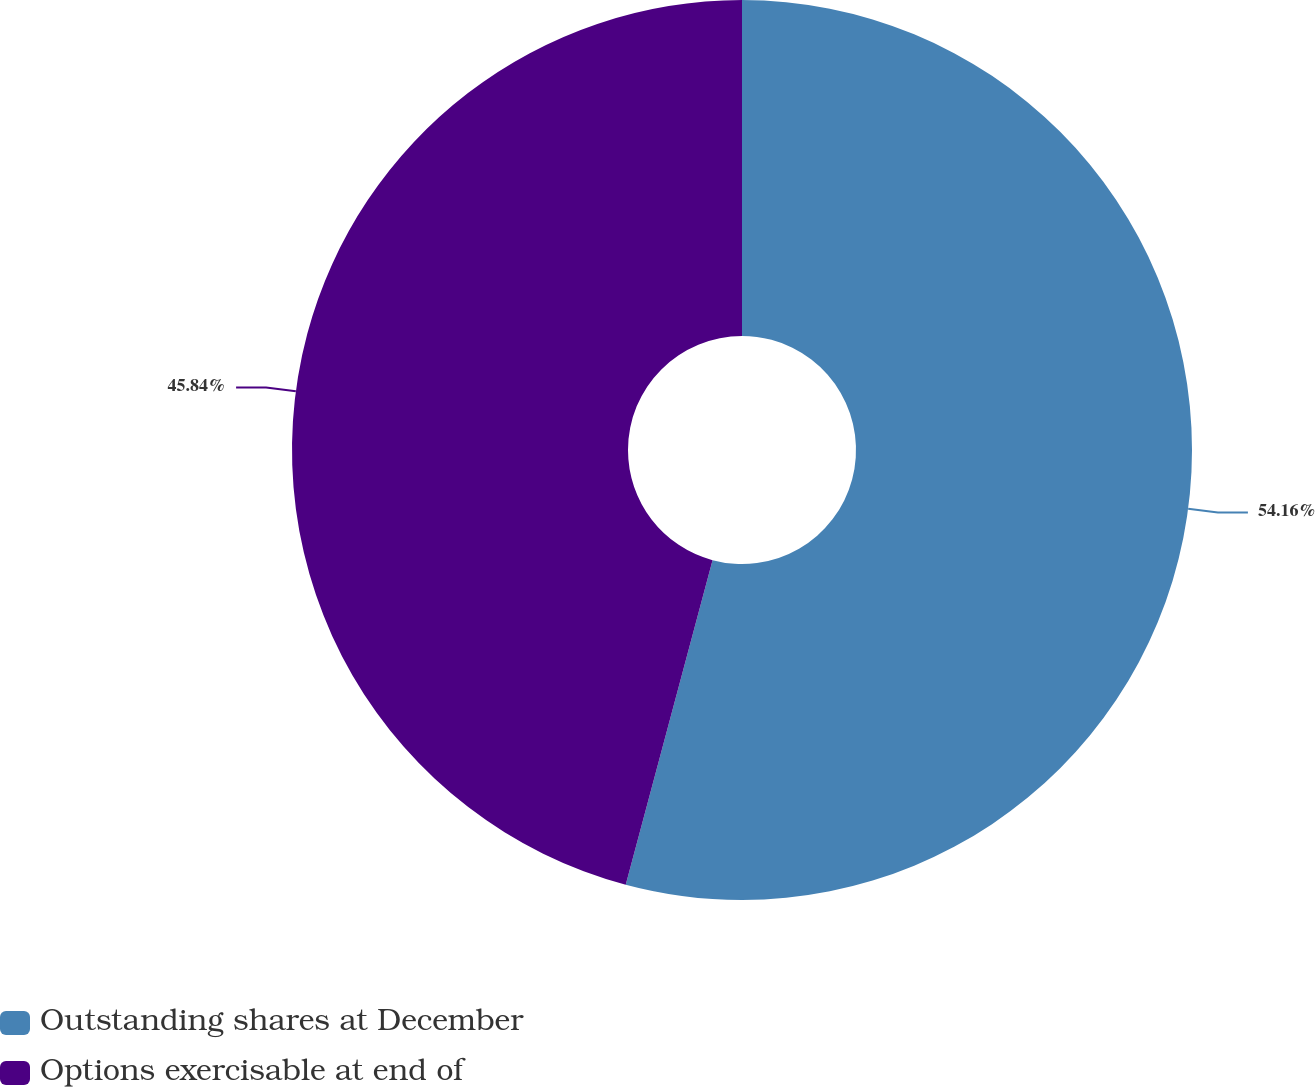Convert chart. <chart><loc_0><loc_0><loc_500><loc_500><pie_chart><fcel>Outstanding shares at December<fcel>Options exercisable at end of<nl><fcel>54.16%<fcel>45.84%<nl></chart> 